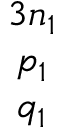<formula> <loc_0><loc_0><loc_500><loc_500>\begin{array} { c } { 3 n _ { 1 } } \\ { p _ { 1 } } \\ { q _ { 1 } } \end{array}</formula> 